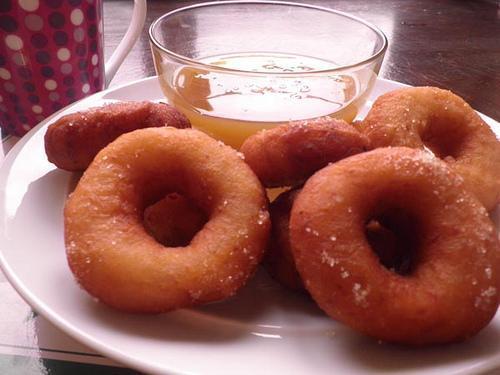How many donuts are visible?
Give a very brief answer. 5. How many bowls are visible?
Give a very brief answer. 1. How many cups are there?
Give a very brief answer. 1. 